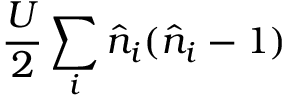Convert formula to latex. <formula><loc_0><loc_0><loc_500><loc_500>\frac { U } { 2 } \sum _ { i } \hat { n } _ { i } ( \hat { n } _ { i } - 1 )</formula> 